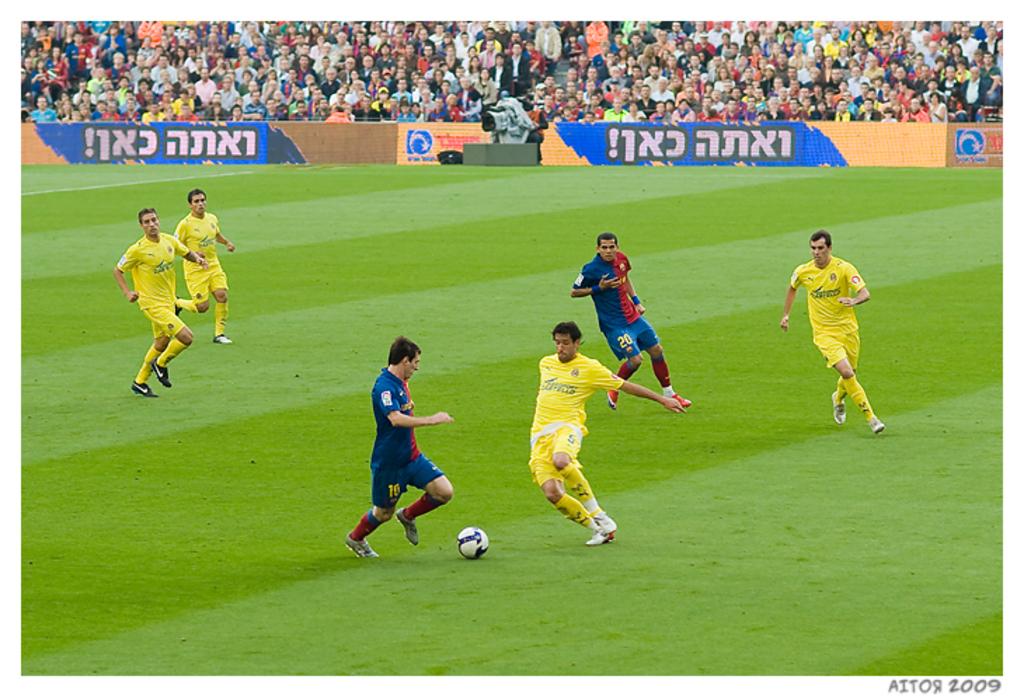What year was this pic taken?
Offer a very short reply. 2009. 